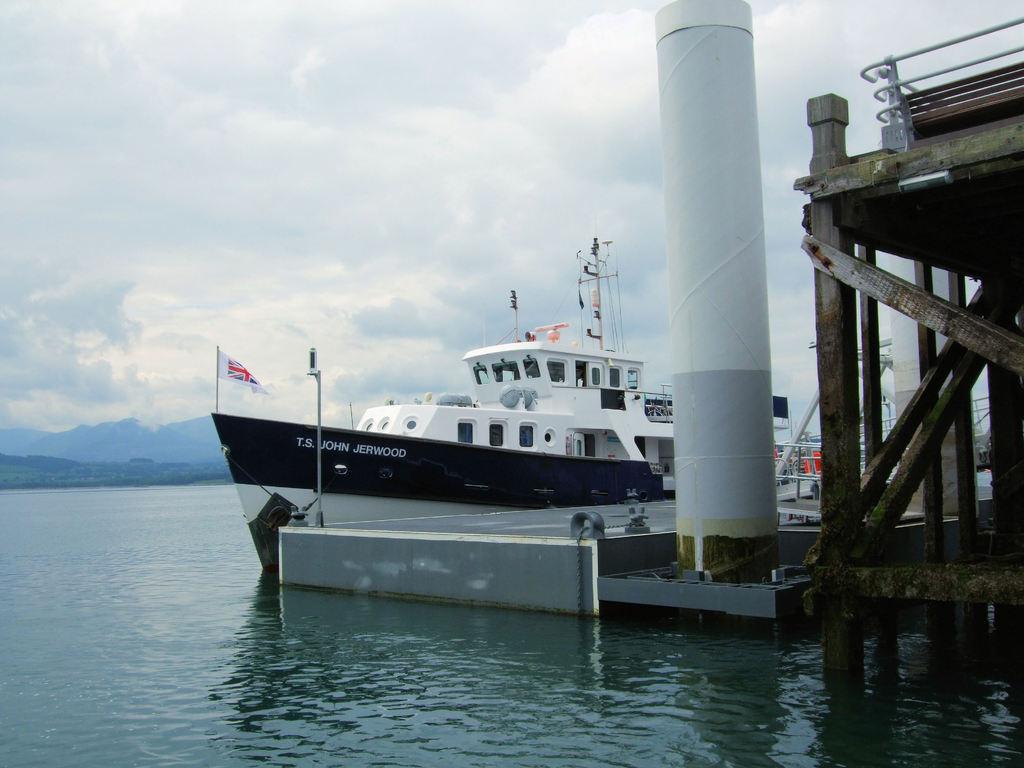What´s the name of the boat?
Give a very brief answer. T.s. john jerwood. 